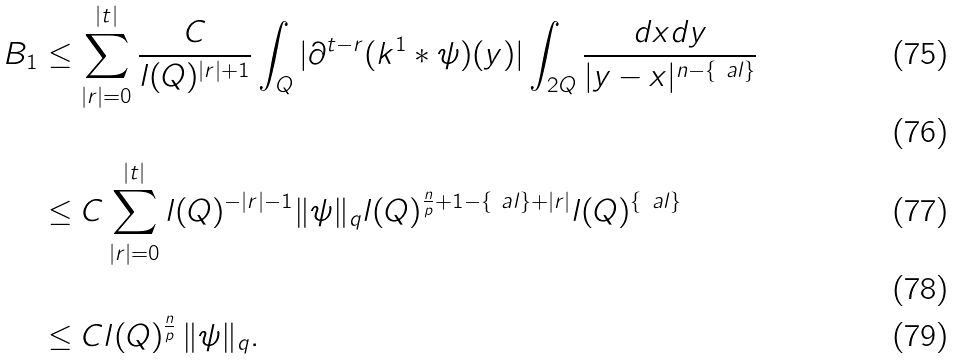<formula> <loc_0><loc_0><loc_500><loc_500>B _ { 1 } & \leq \sum _ { | r | = 0 } ^ { | t | } \frac { C } { l ( Q ) ^ { | r | + 1 } } \int _ { Q } | \partial ^ { t - r } ( k ^ { 1 } * \psi ) ( y ) | \int _ { 2 Q } \frac { d x d y } { | y - x | ^ { n - \{ \ a l \} } } \\ \\ & \leq C \sum _ { | r | = 0 } ^ { | t | } l ( Q ) ^ { - | r | - 1 } \| \psi \| _ { q } l ( Q ) ^ { \frac { n } { p } + 1 - \{ \ a l \} + | r | } l ( Q ) ^ { \{ \ a l \} } \\ \\ & \leq C l ( Q ) ^ { \frac { n } { p } } \, \| \psi \| _ { q } .</formula> 